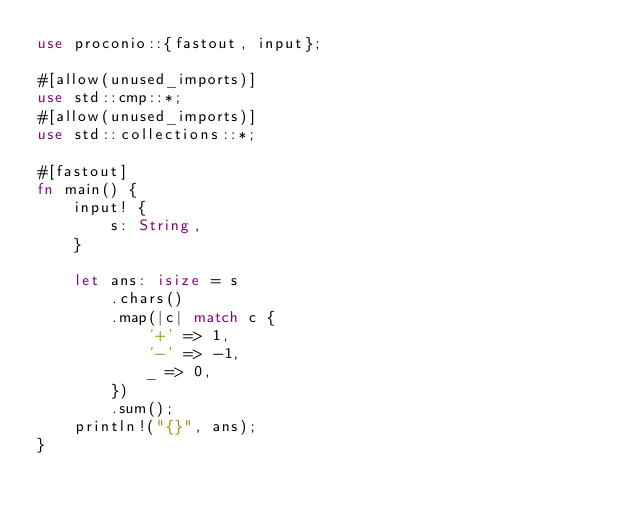<code> <loc_0><loc_0><loc_500><loc_500><_Rust_>use proconio::{fastout, input};

#[allow(unused_imports)]
use std::cmp::*;
#[allow(unused_imports)]
use std::collections::*;

#[fastout]
fn main() {
    input! {
        s: String,
    }

    let ans: isize = s
        .chars()
        .map(|c| match c {
            '+' => 1,
            '-' => -1,
            _ => 0,
        })
        .sum();
    println!("{}", ans);
}
</code> 